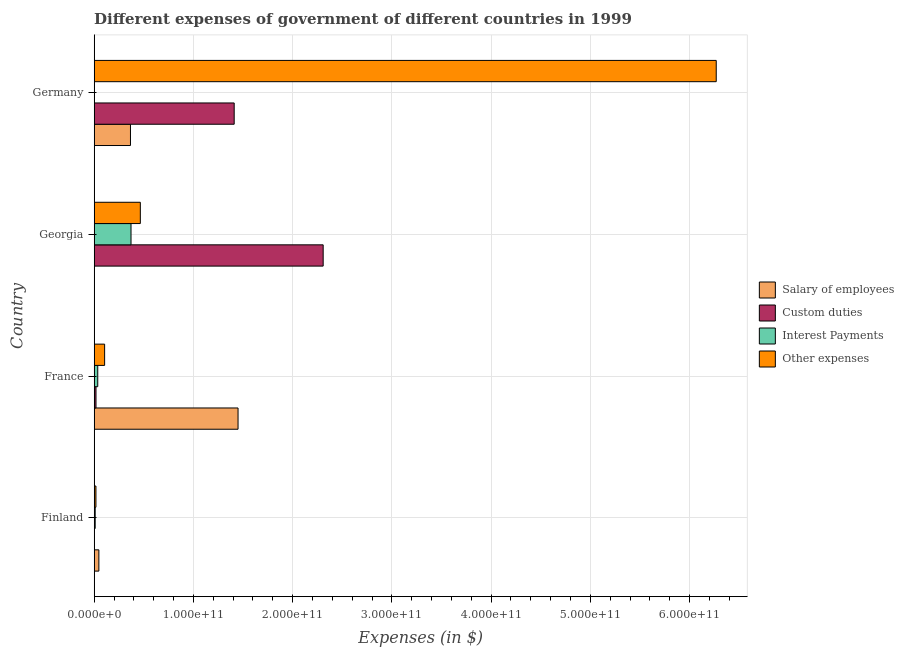How many groups of bars are there?
Provide a short and direct response. 4. Are the number of bars per tick equal to the number of legend labels?
Give a very brief answer. Yes. How many bars are there on the 4th tick from the top?
Your response must be concise. 4. In how many cases, is the number of bars for a given country not equal to the number of legend labels?
Your answer should be very brief. 0. What is the amount spent on interest payments in Germany?
Provide a succinct answer. 1.49e+08. Across all countries, what is the maximum amount spent on interest payments?
Your answer should be very brief. 3.71e+1. Across all countries, what is the minimum amount spent on interest payments?
Make the answer very short. 1.49e+08. In which country was the amount spent on interest payments maximum?
Your answer should be compact. Georgia. In which country was the amount spent on salary of employees minimum?
Your response must be concise. Georgia. What is the total amount spent on salary of employees in the graph?
Make the answer very short. 1.86e+11. What is the difference between the amount spent on other expenses in Finland and that in Georgia?
Give a very brief answer. -4.47e+1. What is the difference between the amount spent on salary of employees in Finland and the amount spent on interest payments in France?
Ensure brevity in your answer.  1.13e+09. What is the average amount spent on custom duties per country?
Your answer should be compact. 9.34e+1. What is the difference between the amount spent on custom duties and amount spent on salary of employees in Georgia?
Give a very brief answer. 2.31e+11. In how many countries, is the amount spent on other expenses greater than 220000000000 $?
Offer a very short reply. 1. Is the difference between the amount spent on salary of employees in Finland and Georgia greater than the difference between the amount spent on custom duties in Finland and Georgia?
Make the answer very short. Yes. What is the difference between the highest and the second highest amount spent on other expenses?
Your answer should be very brief. 5.80e+11. What is the difference between the highest and the lowest amount spent on interest payments?
Make the answer very short. 3.70e+1. What does the 2nd bar from the top in Finland represents?
Ensure brevity in your answer.  Interest Payments. What does the 2nd bar from the bottom in Finland represents?
Provide a succinct answer. Custom duties. Is it the case that in every country, the sum of the amount spent on salary of employees and amount spent on custom duties is greater than the amount spent on interest payments?
Give a very brief answer. Yes. How many bars are there?
Your response must be concise. 16. What is the difference between two consecutive major ticks on the X-axis?
Your answer should be very brief. 1.00e+11. Are the values on the major ticks of X-axis written in scientific E-notation?
Keep it short and to the point. Yes. Where does the legend appear in the graph?
Offer a terse response. Center right. How are the legend labels stacked?
Keep it short and to the point. Vertical. What is the title of the graph?
Your answer should be compact. Different expenses of government of different countries in 1999. What is the label or title of the X-axis?
Your response must be concise. Expenses (in $). What is the label or title of the Y-axis?
Give a very brief answer. Country. What is the Expenses (in $) in Salary of employees in Finland?
Provide a succinct answer. 4.71e+09. What is the Expenses (in $) of Custom duties in Finland?
Give a very brief answer. 3.21e+07. What is the Expenses (in $) in Interest Payments in Finland?
Ensure brevity in your answer.  1.00e+09. What is the Expenses (in $) of Other expenses in Finland?
Give a very brief answer. 1.75e+09. What is the Expenses (in $) of Salary of employees in France?
Your answer should be very brief. 1.45e+11. What is the Expenses (in $) of Custom duties in France?
Give a very brief answer. 1.81e+09. What is the Expenses (in $) in Interest Payments in France?
Offer a terse response. 3.58e+09. What is the Expenses (in $) of Other expenses in France?
Give a very brief answer. 1.05e+1. What is the Expenses (in $) in Salary of employees in Georgia?
Your answer should be very brief. 1.07e+08. What is the Expenses (in $) of Custom duties in Georgia?
Provide a succinct answer. 2.31e+11. What is the Expenses (in $) in Interest Payments in Georgia?
Your response must be concise. 3.71e+1. What is the Expenses (in $) of Other expenses in Georgia?
Offer a very short reply. 4.65e+1. What is the Expenses (in $) in Salary of employees in Germany?
Provide a short and direct response. 3.66e+1. What is the Expenses (in $) of Custom duties in Germany?
Make the answer very short. 1.41e+11. What is the Expenses (in $) of Interest Payments in Germany?
Your response must be concise. 1.49e+08. What is the Expenses (in $) of Other expenses in Germany?
Give a very brief answer. 6.27e+11. Across all countries, what is the maximum Expenses (in $) in Salary of employees?
Your answer should be compact. 1.45e+11. Across all countries, what is the maximum Expenses (in $) in Custom duties?
Offer a very short reply. 2.31e+11. Across all countries, what is the maximum Expenses (in $) in Interest Payments?
Your response must be concise. 3.71e+1. Across all countries, what is the maximum Expenses (in $) in Other expenses?
Make the answer very short. 6.27e+11. Across all countries, what is the minimum Expenses (in $) of Salary of employees?
Your answer should be very brief. 1.07e+08. Across all countries, what is the minimum Expenses (in $) of Custom duties?
Offer a terse response. 3.21e+07. Across all countries, what is the minimum Expenses (in $) of Interest Payments?
Your answer should be very brief. 1.49e+08. Across all countries, what is the minimum Expenses (in $) of Other expenses?
Keep it short and to the point. 1.75e+09. What is the total Expenses (in $) of Salary of employees in the graph?
Your answer should be compact. 1.86e+11. What is the total Expenses (in $) in Custom duties in the graph?
Ensure brevity in your answer.  3.74e+11. What is the total Expenses (in $) of Interest Payments in the graph?
Your answer should be compact. 4.18e+1. What is the total Expenses (in $) of Other expenses in the graph?
Give a very brief answer. 6.86e+11. What is the difference between the Expenses (in $) of Salary of employees in Finland and that in France?
Keep it short and to the point. -1.40e+11. What is the difference between the Expenses (in $) of Custom duties in Finland and that in France?
Give a very brief answer. -1.78e+09. What is the difference between the Expenses (in $) in Interest Payments in Finland and that in France?
Your response must be concise. -2.58e+09. What is the difference between the Expenses (in $) in Other expenses in Finland and that in France?
Give a very brief answer. -8.75e+09. What is the difference between the Expenses (in $) of Salary of employees in Finland and that in Georgia?
Make the answer very short. 4.61e+09. What is the difference between the Expenses (in $) of Custom duties in Finland and that in Georgia?
Your answer should be compact. -2.31e+11. What is the difference between the Expenses (in $) of Interest Payments in Finland and that in Georgia?
Your response must be concise. -3.61e+1. What is the difference between the Expenses (in $) of Other expenses in Finland and that in Georgia?
Offer a very short reply. -4.47e+1. What is the difference between the Expenses (in $) in Salary of employees in Finland and that in Germany?
Give a very brief answer. -3.18e+1. What is the difference between the Expenses (in $) in Custom duties in Finland and that in Germany?
Offer a very short reply. -1.41e+11. What is the difference between the Expenses (in $) in Interest Payments in Finland and that in Germany?
Offer a very short reply. 8.54e+08. What is the difference between the Expenses (in $) of Other expenses in Finland and that in Germany?
Provide a short and direct response. -6.25e+11. What is the difference between the Expenses (in $) in Salary of employees in France and that in Georgia?
Make the answer very short. 1.45e+11. What is the difference between the Expenses (in $) of Custom duties in France and that in Georgia?
Make the answer very short. -2.29e+11. What is the difference between the Expenses (in $) in Interest Payments in France and that in Georgia?
Give a very brief answer. -3.35e+1. What is the difference between the Expenses (in $) of Other expenses in France and that in Georgia?
Make the answer very short. -3.60e+1. What is the difference between the Expenses (in $) of Salary of employees in France and that in Germany?
Your answer should be very brief. 1.08e+11. What is the difference between the Expenses (in $) in Custom duties in France and that in Germany?
Give a very brief answer. -1.39e+11. What is the difference between the Expenses (in $) in Interest Payments in France and that in Germany?
Provide a succinct answer. 3.44e+09. What is the difference between the Expenses (in $) in Other expenses in France and that in Germany?
Your response must be concise. -6.16e+11. What is the difference between the Expenses (in $) of Salary of employees in Georgia and that in Germany?
Make the answer very short. -3.64e+1. What is the difference between the Expenses (in $) of Custom duties in Georgia and that in Germany?
Provide a succinct answer. 8.97e+1. What is the difference between the Expenses (in $) of Interest Payments in Georgia and that in Germany?
Make the answer very short. 3.70e+1. What is the difference between the Expenses (in $) in Other expenses in Georgia and that in Germany?
Keep it short and to the point. -5.80e+11. What is the difference between the Expenses (in $) in Salary of employees in Finland and the Expenses (in $) in Custom duties in France?
Your answer should be very brief. 2.90e+09. What is the difference between the Expenses (in $) in Salary of employees in Finland and the Expenses (in $) in Interest Payments in France?
Your response must be concise. 1.13e+09. What is the difference between the Expenses (in $) of Salary of employees in Finland and the Expenses (in $) of Other expenses in France?
Provide a short and direct response. -5.79e+09. What is the difference between the Expenses (in $) in Custom duties in Finland and the Expenses (in $) in Interest Payments in France?
Ensure brevity in your answer.  -3.55e+09. What is the difference between the Expenses (in $) of Custom duties in Finland and the Expenses (in $) of Other expenses in France?
Your answer should be very brief. -1.05e+1. What is the difference between the Expenses (in $) of Interest Payments in Finland and the Expenses (in $) of Other expenses in France?
Your answer should be very brief. -9.50e+09. What is the difference between the Expenses (in $) of Salary of employees in Finland and the Expenses (in $) of Custom duties in Georgia?
Ensure brevity in your answer.  -2.26e+11. What is the difference between the Expenses (in $) in Salary of employees in Finland and the Expenses (in $) in Interest Payments in Georgia?
Keep it short and to the point. -3.24e+1. What is the difference between the Expenses (in $) of Salary of employees in Finland and the Expenses (in $) of Other expenses in Georgia?
Offer a very short reply. -4.18e+1. What is the difference between the Expenses (in $) of Custom duties in Finland and the Expenses (in $) of Interest Payments in Georgia?
Make the answer very short. -3.71e+1. What is the difference between the Expenses (in $) of Custom duties in Finland and the Expenses (in $) of Other expenses in Georgia?
Your response must be concise. -4.65e+1. What is the difference between the Expenses (in $) of Interest Payments in Finland and the Expenses (in $) of Other expenses in Georgia?
Provide a short and direct response. -4.55e+1. What is the difference between the Expenses (in $) in Salary of employees in Finland and the Expenses (in $) in Custom duties in Germany?
Keep it short and to the point. -1.36e+11. What is the difference between the Expenses (in $) of Salary of employees in Finland and the Expenses (in $) of Interest Payments in Germany?
Offer a very short reply. 4.57e+09. What is the difference between the Expenses (in $) in Salary of employees in Finland and the Expenses (in $) in Other expenses in Germany?
Make the answer very short. -6.22e+11. What is the difference between the Expenses (in $) of Custom duties in Finland and the Expenses (in $) of Interest Payments in Germany?
Your answer should be very brief. -1.16e+08. What is the difference between the Expenses (in $) of Custom duties in Finland and the Expenses (in $) of Other expenses in Germany?
Offer a terse response. -6.27e+11. What is the difference between the Expenses (in $) in Interest Payments in Finland and the Expenses (in $) in Other expenses in Germany?
Give a very brief answer. -6.26e+11. What is the difference between the Expenses (in $) of Salary of employees in France and the Expenses (in $) of Custom duties in Georgia?
Make the answer very short. -8.58e+1. What is the difference between the Expenses (in $) of Salary of employees in France and the Expenses (in $) of Interest Payments in Georgia?
Provide a short and direct response. 1.08e+11. What is the difference between the Expenses (in $) of Salary of employees in France and the Expenses (in $) of Other expenses in Georgia?
Your answer should be very brief. 9.85e+1. What is the difference between the Expenses (in $) of Custom duties in France and the Expenses (in $) of Interest Payments in Georgia?
Give a very brief answer. -3.53e+1. What is the difference between the Expenses (in $) in Custom duties in France and the Expenses (in $) in Other expenses in Georgia?
Your response must be concise. -4.47e+1. What is the difference between the Expenses (in $) of Interest Payments in France and the Expenses (in $) of Other expenses in Georgia?
Offer a terse response. -4.29e+1. What is the difference between the Expenses (in $) in Salary of employees in France and the Expenses (in $) in Custom duties in Germany?
Ensure brevity in your answer.  3.90e+09. What is the difference between the Expenses (in $) of Salary of employees in France and the Expenses (in $) of Interest Payments in Germany?
Ensure brevity in your answer.  1.45e+11. What is the difference between the Expenses (in $) of Salary of employees in France and the Expenses (in $) of Other expenses in Germany?
Your response must be concise. -4.82e+11. What is the difference between the Expenses (in $) in Custom duties in France and the Expenses (in $) in Interest Payments in Germany?
Your answer should be compact. 1.67e+09. What is the difference between the Expenses (in $) of Custom duties in France and the Expenses (in $) of Other expenses in Germany?
Make the answer very short. -6.25e+11. What is the difference between the Expenses (in $) of Interest Payments in France and the Expenses (in $) of Other expenses in Germany?
Your response must be concise. -6.23e+11. What is the difference between the Expenses (in $) of Salary of employees in Georgia and the Expenses (in $) of Custom duties in Germany?
Make the answer very short. -1.41e+11. What is the difference between the Expenses (in $) in Salary of employees in Georgia and the Expenses (in $) in Interest Payments in Germany?
Offer a very short reply. -4.14e+07. What is the difference between the Expenses (in $) of Salary of employees in Georgia and the Expenses (in $) of Other expenses in Germany?
Make the answer very short. -6.27e+11. What is the difference between the Expenses (in $) in Custom duties in Georgia and the Expenses (in $) in Interest Payments in Germany?
Your response must be concise. 2.31e+11. What is the difference between the Expenses (in $) of Custom duties in Georgia and the Expenses (in $) of Other expenses in Germany?
Provide a short and direct response. -3.96e+11. What is the difference between the Expenses (in $) in Interest Payments in Georgia and the Expenses (in $) in Other expenses in Germany?
Your response must be concise. -5.90e+11. What is the average Expenses (in $) of Salary of employees per country?
Your answer should be very brief. 4.66e+1. What is the average Expenses (in $) of Custom duties per country?
Offer a very short reply. 9.34e+1. What is the average Expenses (in $) in Interest Payments per country?
Ensure brevity in your answer.  1.05e+1. What is the average Expenses (in $) in Other expenses per country?
Ensure brevity in your answer.  1.71e+11. What is the difference between the Expenses (in $) in Salary of employees and Expenses (in $) in Custom duties in Finland?
Provide a succinct answer. 4.68e+09. What is the difference between the Expenses (in $) in Salary of employees and Expenses (in $) in Interest Payments in Finland?
Provide a short and direct response. 3.71e+09. What is the difference between the Expenses (in $) in Salary of employees and Expenses (in $) in Other expenses in Finland?
Your answer should be compact. 2.97e+09. What is the difference between the Expenses (in $) of Custom duties and Expenses (in $) of Interest Payments in Finland?
Your answer should be very brief. -9.70e+08. What is the difference between the Expenses (in $) in Custom duties and Expenses (in $) in Other expenses in Finland?
Make the answer very short. -1.72e+09. What is the difference between the Expenses (in $) in Interest Payments and Expenses (in $) in Other expenses in Finland?
Provide a short and direct response. -7.46e+08. What is the difference between the Expenses (in $) of Salary of employees and Expenses (in $) of Custom duties in France?
Keep it short and to the point. 1.43e+11. What is the difference between the Expenses (in $) in Salary of employees and Expenses (in $) in Interest Payments in France?
Offer a very short reply. 1.41e+11. What is the difference between the Expenses (in $) in Salary of employees and Expenses (in $) in Other expenses in France?
Make the answer very short. 1.34e+11. What is the difference between the Expenses (in $) in Custom duties and Expenses (in $) in Interest Payments in France?
Give a very brief answer. -1.77e+09. What is the difference between the Expenses (in $) in Custom duties and Expenses (in $) in Other expenses in France?
Give a very brief answer. -8.69e+09. What is the difference between the Expenses (in $) in Interest Payments and Expenses (in $) in Other expenses in France?
Give a very brief answer. -6.92e+09. What is the difference between the Expenses (in $) of Salary of employees and Expenses (in $) of Custom duties in Georgia?
Your answer should be very brief. -2.31e+11. What is the difference between the Expenses (in $) of Salary of employees and Expenses (in $) of Interest Payments in Georgia?
Make the answer very short. -3.70e+1. What is the difference between the Expenses (in $) of Salary of employees and Expenses (in $) of Other expenses in Georgia?
Offer a very short reply. -4.64e+1. What is the difference between the Expenses (in $) of Custom duties and Expenses (in $) of Interest Payments in Georgia?
Provide a succinct answer. 1.94e+11. What is the difference between the Expenses (in $) of Custom duties and Expenses (in $) of Other expenses in Georgia?
Offer a very short reply. 1.84e+11. What is the difference between the Expenses (in $) in Interest Payments and Expenses (in $) in Other expenses in Georgia?
Offer a very short reply. -9.39e+09. What is the difference between the Expenses (in $) in Salary of employees and Expenses (in $) in Custom duties in Germany?
Give a very brief answer. -1.05e+11. What is the difference between the Expenses (in $) in Salary of employees and Expenses (in $) in Interest Payments in Germany?
Provide a succinct answer. 3.64e+1. What is the difference between the Expenses (in $) in Salary of employees and Expenses (in $) in Other expenses in Germany?
Ensure brevity in your answer.  -5.90e+11. What is the difference between the Expenses (in $) of Custom duties and Expenses (in $) of Interest Payments in Germany?
Your response must be concise. 1.41e+11. What is the difference between the Expenses (in $) of Custom duties and Expenses (in $) of Other expenses in Germany?
Your answer should be compact. -4.86e+11. What is the difference between the Expenses (in $) of Interest Payments and Expenses (in $) of Other expenses in Germany?
Provide a short and direct response. -6.27e+11. What is the ratio of the Expenses (in $) in Salary of employees in Finland to that in France?
Provide a succinct answer. 0.03. What is the ratio of the Expenses (in $) in Custom duties in Finland to that in France?
Offer a terse response. 0.02. What is the ratio of the Expenses (in $) of Interest Payments in Finland to that in France?
Offer a very short reply. 0.28. What is the ratio of the Expenses (in $) of Other expenses in Finland to that in France?
Offer a terse response. 0.17. What is the ratio of the Expenses (in $) in Salary of employees in Finland to that in Georgia?
Give a very brief answer. 43.97. What is the ratio of the Expenses (in $) of Interest Payments in Finland to that in Georgia?
Ensure brevity in your answer.  0.03. What is the ratio of the Expenses (in $) of Other expenses in Finland to that in Georgia?
Offer a very short reply. 0.04. What is the ratio of the Expenses (in $) in Salary of employees in Finland to that in Germany?
Offer a terse response. 0.13. What is the ratio of the Expenses (in $) of Interest Payments in Finland to that in Germany?
Ensure brevity in your answer.  6.75. What is the ratio of the Expenses (in $) in Other expenses in Finland to that in Germany?
Your answer should be very brief. 0. What is the ratio of the Expenses (in $) of Salary of employees in France to that in Georgia?
Make the answer very short. 1352.4. What is the ratio of the Expenses (in $) of Custom duties in France to that in Georgia?
Offer a terse response. 0.01. What is the ratio of the Expenses (in $) of Interest Payments in France to that in Georgia?
Your answer should be very brief. 0.1. What is the ratio of the Expenses (in $) in Other expenses in France to that in Georgia?
Keep it short and to the point. 0.23. What is the ratio of the Expenses (in $) in Salary of employees in France to that in Germany?
Offer a terse response. 3.97. What is the ratio of the Expenses (in $) of Custom duties in France to that in Germany?
Keep it short and to the point. 0.01. What is the ratio of the Expenses (in $) of Interest Payments in France to that in Germany?
Keep it short and to the point. 24.12. What is the ratio of the Expenses (in $) of Other expenses in France to that in Germany?
Offer a terse response. 0.02. What is the ratio of the Expenses (in $) of Salary of employees in Georgia to that in Germany?
Offer a very short reply. 0. What is the ratio of the Expenses (in $) of Custom duties in Georgia to that in Germany?
Your answer should be compact. 1.64. What is the ratio of the Expenses (in $) of Interest Payments in Georgia to that in Germany?
Provide a short and direct response. 249.72. What is the ratio of the Expenses (in $) in Other expenses in Georgia to that in Germany?
Offer a terse response. 0.07. What is the difference between the highest and the second highest Expenses (in $) of Salary of employees?
Provide a succinct answer. 1.08e+11. What is the difference between the highest and the second highest Expenses (in $) in Custom duties?
Give a very brief answer. 8.97e+1. What is the difference between the highest and the second highest Expenses (in $) of Interest Payments?
Offer a very short reply. 3.35e+1. What is the difference between the highest and the second highest Expenses (in $) of Other expenses?
Your answer should be compact. 5.80e+11. What is the difference between the highest and the lowest Expenses (in $) of Salary of employees?
Make the answer very short. 1.45e+11. What is the difference between the highest and the lowest Expenses (in $) in Custom duties?
Your response must be concise. 2.31e+11. What is the difference between the highest and the lowest Expenses (in $) of Interest Payments?
Ensure brevity in your answer.  3.70e+1. What is the difference between the highest and the lowest Expenses (in $) of Other expenses?
Offer a very short reply. 6.25e+11. 